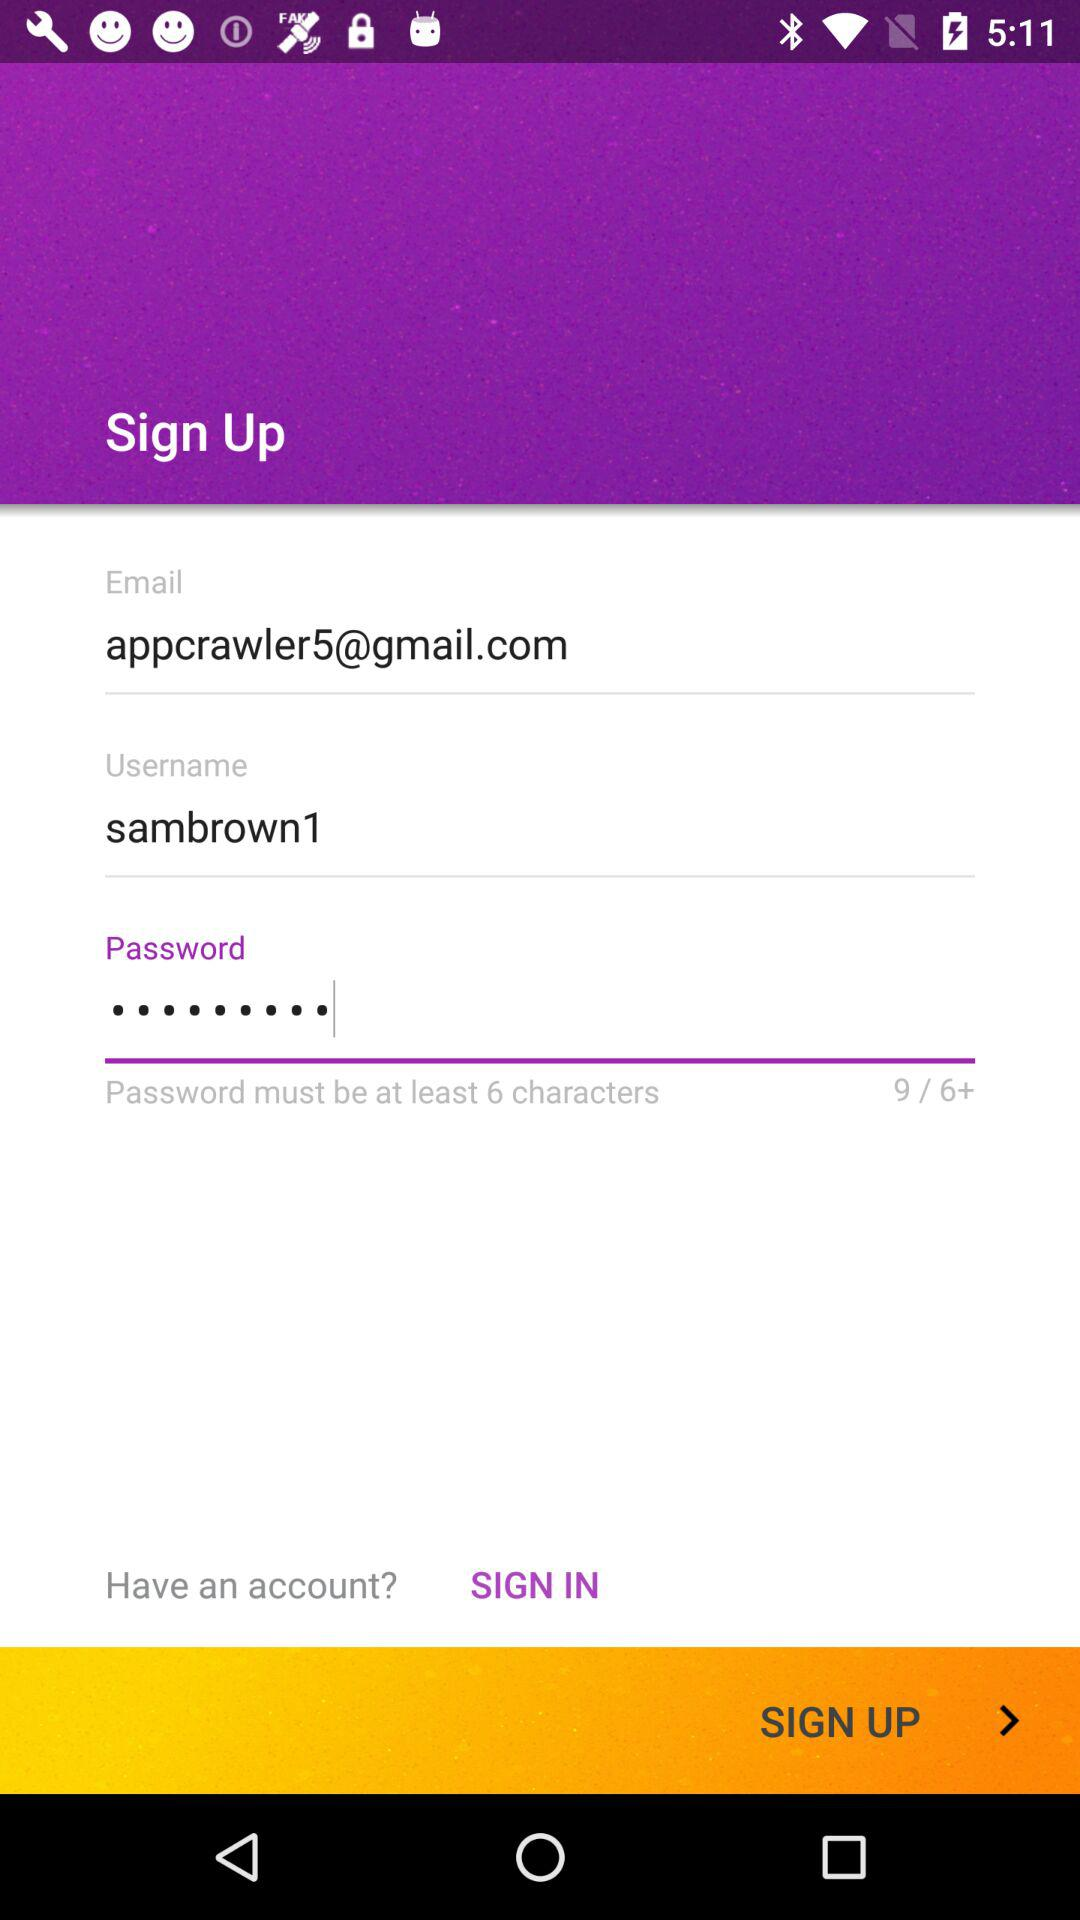How many characters must be in the password? There must be at least 6 characters in the password. 